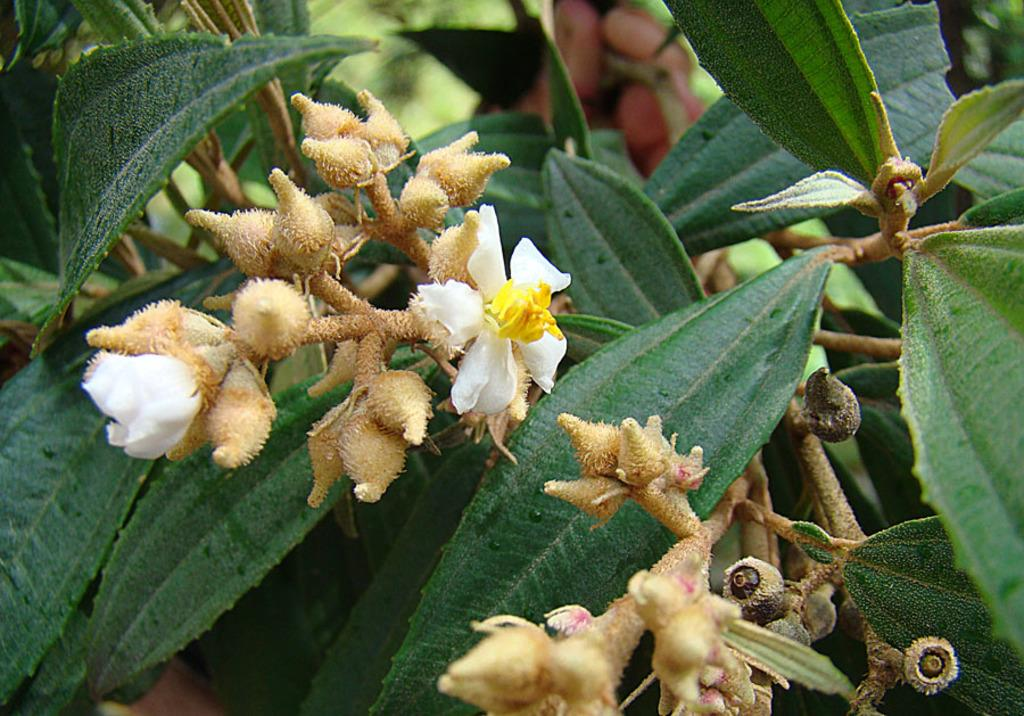What type of living organisms can be seen in the image? There are flowers and plants in the image. Can you describe the plants in the image? The plants in the image are not specified, but they are present alongside the flowers. What type of building can be seen on fire in the image? There is no building or fire present in the image; it only features flowers and plants. 